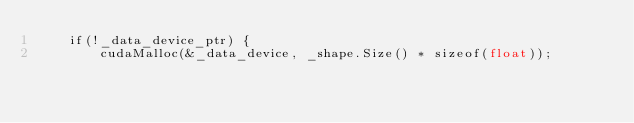Convert code to text. <code><loc_0><loc_0><loc_500><loc_500><_Cuda_>    if(!_data_device_ptr) {
        cudaMalloc(&_data_device, _shape.Size() * sizeof(float));</code> 